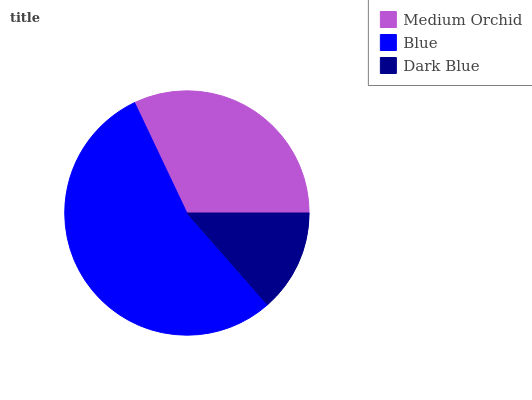Is Dark Blue the minimum?
Answer yes or no. Yes. Is Blue the maximum?
Answer yes or no. Yes. Is Blue the minimum?
Answer yes or no. No. Is Dark Blue the maximum?
Answer yes or no. No. Is Blue greater than Dark Blue?
Answer yes or no. Yes. Is Dark Blue less than Blue?
Answer yes or no. Yes. Is Dark Blue greater than Blue?
Answer yes or no. No. Is Blue less than Dark Blue?
Answer yes or no. No. Is Medium Orchid the high median?
Answer yes or no. Yes. Is Medium Orchid the low median?
Answer yes or no. Yes. Is Blue the high median?
Answer yes or no. No. Is Dark Blue the low median?
Answer yes or no. No. 